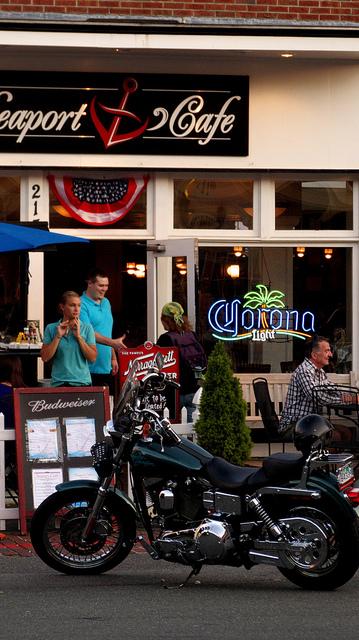What is the name of the cafe?
Quick response, please. Seaport cafe. How many motorcycles are pictured?
Be succinct. 1. What beer is advertised on the window?
Answer briefly. Corona. 